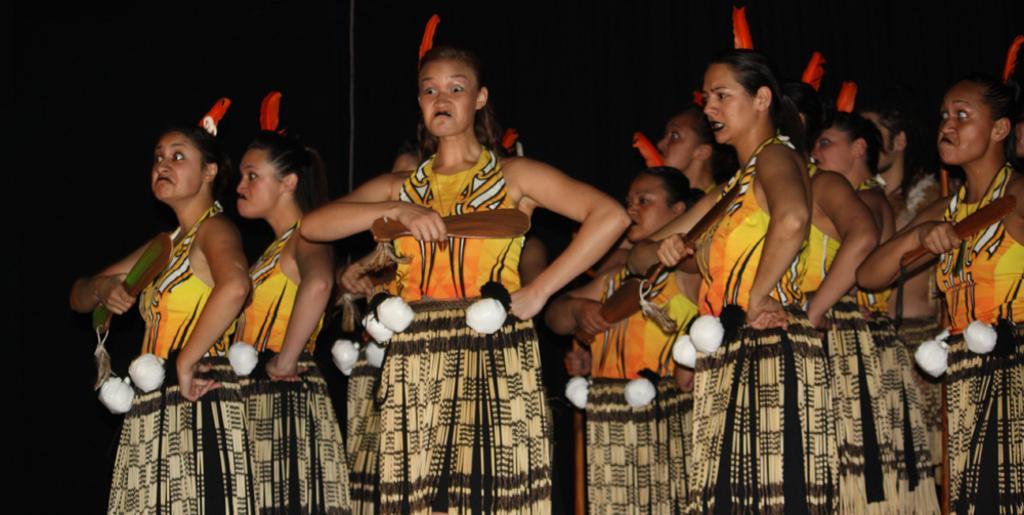Describe this image in one or two sentences. In this image we can see a group of women wearing the costumes standing holding the wooden sticks. 